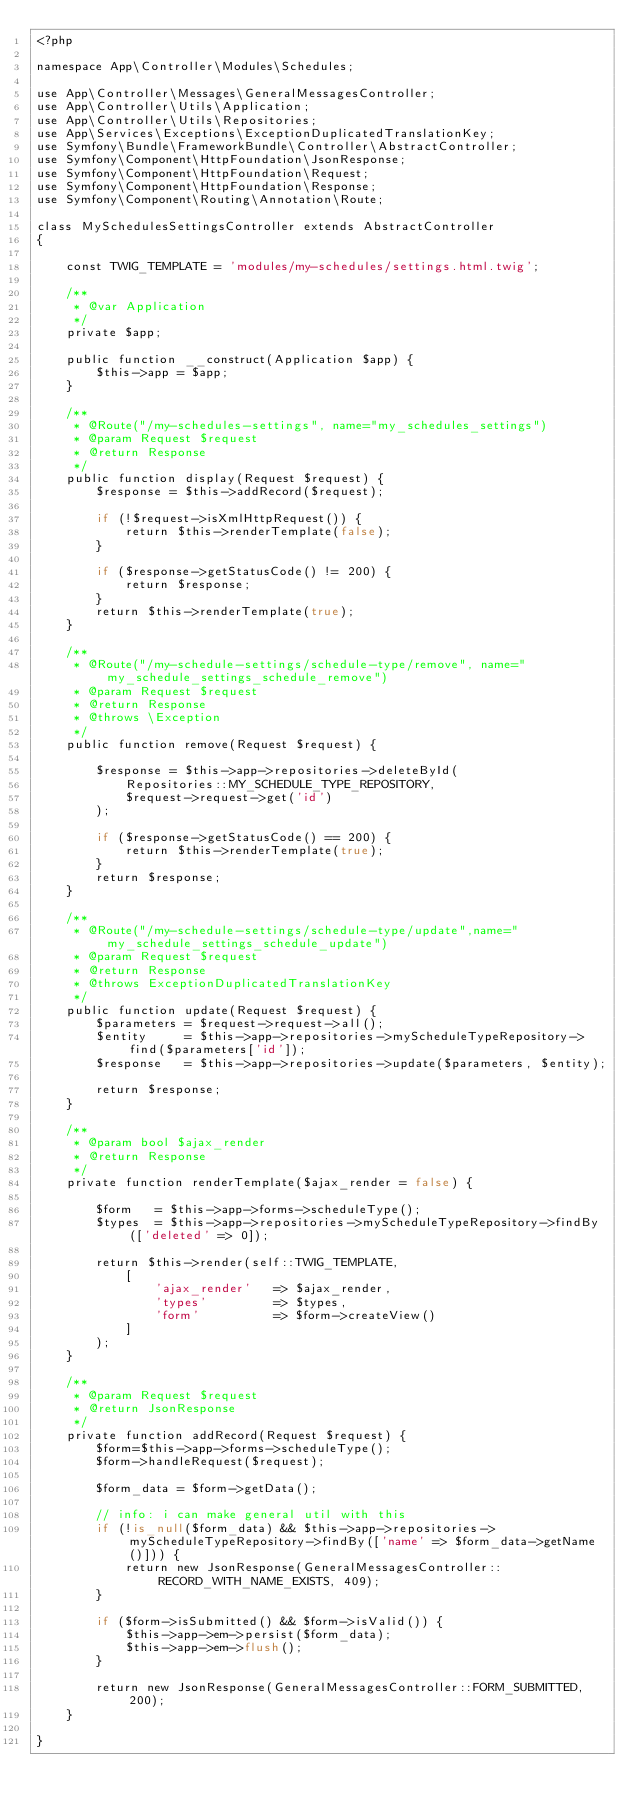<code> <loc_0><loc_0><loc_500><loc_500><_PHP_><?php

namespace App\Controller\Modules\Schedules;

use App\Controller\Messages\GeneralMessagesController;
use App\Controller\Utils\Application;
use App\Controller\Utils\Repositories;
use App\Services\Exceptions\ExceptionDuplicatedTranslationKey;
use Symfony\Bundle\FrameworkBundle\Controller\AbstractController;
use Symfony\Component\HttpFoundation\JsonResponse;
use Symfony\Component\HttpFoundation\Request;
use Symfony\Component\HttpFoundation\Response;
use Symfony\Component\Routing\Annotation\Route;

class MySchedulesSettingsController extends AbstractController
{

    const TWIG_TEMPLATE = 'modules/my-schedules/settings.html.twig';

    /**
     * @var Application
     */
    private $app;

    public function __construct(Application $app) {
        $this->app = $app;
    }

    /**
     * @Route("/my-schedules-settings", name="my_schedules_settings")
     * @param Request $request
     * @return Response
     */
    public function display(Request $request) {
        $response = $this->addRecord($request);

        if (!$request->isXmlHttpRequest()) {
            return $this->renderTemplate(false);
        }

        if ($response->getStatusCode() != 200) {
            return $response;
        }
        return $this->renderTemplate(true);
    }

    /**
     * @Route("/my-schedule-settings/schedule-type/remove", name="my_schedule_settings_schedule_remove")
     * @param Request $request
     * @return Response
     * @throws \Exception
     */
    public function remove(Request $request) {

        $response = $this->app->repositories->deleteById(
            Repositories::MY_SCHEDULE_TYPE_REPOSITORY,
            $request->request->get('id')
        );

        if ($response->getStatusCode() == 200) {
            return $this->renderTemplate(true);
        }
        return $response;
    }

    /**
     * @Route("/my-schedule-settings/schedule-type/update",name="my_schedule_settings_schedule_update")
     * @param Request $request
     * @return Response
     * @throws ExceptionDuplicatedTranslationKey
     */
    public function update(Request $request) {
        $parameters = $request->request->all();
        $entity     = $this->app->repositories->myScheduleTypeRepository->find($parameters['id']);
        $response   = $this->app->repositories->update($parameters, $entity);

        return $response;
    }

    /**
     * @param bool $ajax_render
     * @return Response
     */
    private function renderTemplate($ajax_render = false) {

        $form   = $this->app->forms->scheduleType();
        $types  = $this->app->repositories->myScheduleTypeRepository->findBy(['deleted' => 0]);

        return $this->render(self::TWIG_TEMPLATE,
            [
                'ajax_render'   => $ajax_render,
                'types'         => $types,
                'form'          => $form->createView()
            ]
        );
    }

    /**
     * @param Request $request
     * @return JsonResponse
     */
    private function addRecord(Request $request) {
        $form=$this->app->forms->scheduleType();
        $form->handleRequest($request);

        $form_data = $form->getData();

        // info: i can make general util with this
        if (!is_null($form_data) && $this->app->repositories->myScheduleTypeRepository->findBy(['name' => $form_data->getName()])) {
            return new JsonResponse(GeneralMessagesController::RECORD_WITH_NAME_EXISTS, 409);
        }

        if ($form->isSubmitted() && $form->isValid()) {
            $this->app->em->persist($form_data);
            $this->app->em->flush();
        }

        return new JsonResponse(GeneralMessagesController::FORM_SUBMITTED, 200);
    }

}
</code> 